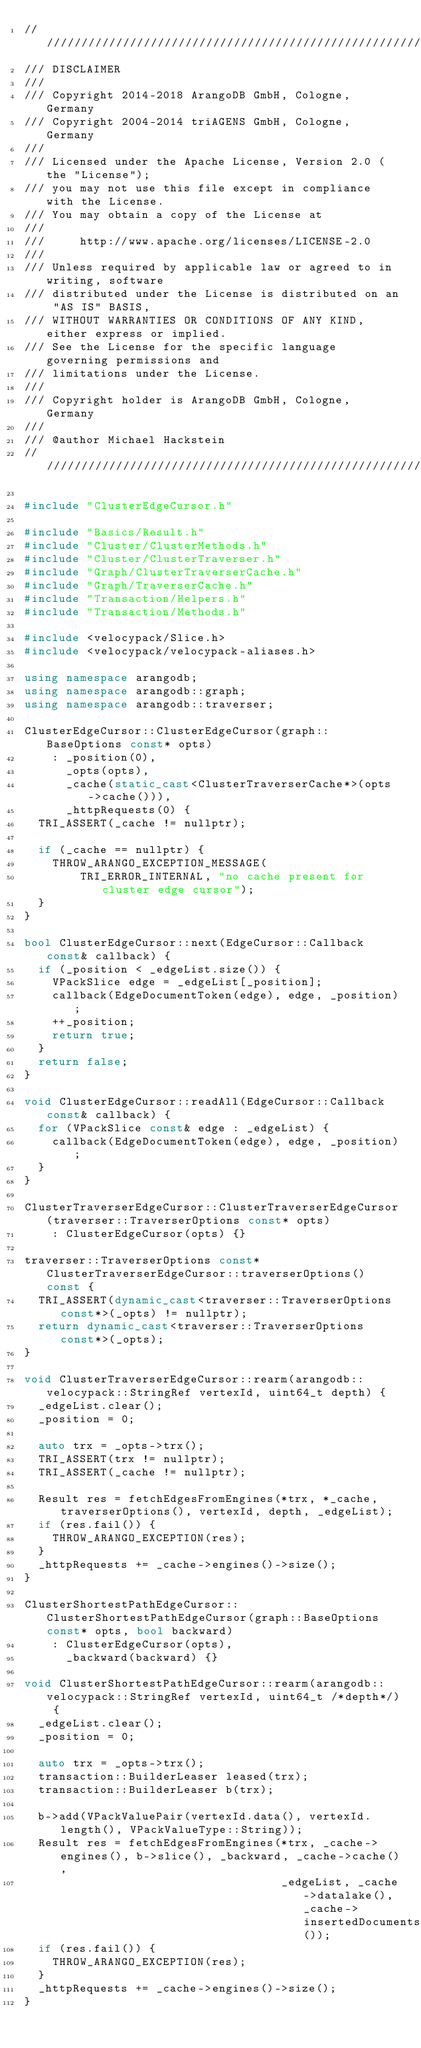<code> <loc_0><loc_0><loc_500><loc_500><_C++_>////////////////////////////////////////////////////////////////////////////////
/// DISCLAIMER
///
/// Copyright 2014-2018 ArangoDB GmbH, Cologne, Germany
/// Copyright 2004-2014 triAGENS GmbH, Cologne, Germany
///
/// Licensed under the Apache License, Version 2.0 (the "License");
/// you may not use this file except in compliance with the License.
/// You may obtain a copy of the License at
///
///     http://www.apache.org/licenses/LICENSE-2.0
///
/// Unless required by applicable law or agreed to in writing, software
/// distributed under the License is distributed on an "AS IS" BASIS,
/// WITHOUT WARRANTIES OR CONDITIONS OF ANY KIND, either express or implied.
/// See the License for the specific language governing permissions and
/// limitations under the License.
///
/// Copyright holder is ArangoDB GmbH, Cologne, Germany
///
/// @author Michael Hackstein
////////////////////////////////////////////////////////////////////////////////

#include "ClusterEdgeCursor.h"

#include "Basics/Result.h"
#include "Cluster/ClusterMethods.h"
#include "Cluster/ClusterTraverser.h"
#include "Graph/ClusterTraverserCache.h"
#include "Graph/TraverserCache.h"
#include "Transaction/Helpers.h"
#include "Transaction/Methods.h"

#include <velocypack/Slice.h>
#include <velocypack/velocypack-aliases.h>

using namespace arangodb;
using namespace arangodb::graph;
using namespace arangodb::traverser;

ClusterEdgeCursor::ClusterEdgeCursor(graph::BaseOptions const* opts) 
    : _position(0),
      _opts(opts),
      _cache(static_cast<ClusterTraverserCache*>(opts->cache())),
      _httpRequests(0) {
  TRI_ASSERT(_cache != nullptr);

  if (_cache == nullptr) {
    THROW_ARANGO_EXCEPTION_MESSAGE(
        TRI_ERROR_INTERNAL, "no cache present for cluster edge cursor");
  }
}

bool ClusterEdgeCursor::next(EdgeCursor::Callback const& callback) {
  if (_position < _edgeList.size()) {
    VPackSlice edge = _edgeList[_position];
    callback(EdgeDocumentToken(edge), edge, _position);
    ++_position;
    return true;
  }
  return false;
}

void ClusterEdgeCursor::readAll(EdgeCursor::Callback const& callback) {
  for (VPackSlice const& edge : _edgeList) {
    callback(EdgeDocumentToken(edge), edge, _position);
  }
}
  
ClusterTraverserEdgeCursor::ClusterTraverserEdgeCursor(traverser::TraverserOptions const* opts)
    : ClusterEdgeCursor(opts) {}

traverser::TraverserOptions const* ClusterTraverserEdgeCursor::traverserOptions() const {
  TRI_ASSERT(dynamic_cast<traverser::TraverserOptions const*>(_opts) != nullptr);
  return dynamic_cast<traverser::TraverserOptions const*>(_opts);
}

void ClusterTraverserEdgeCursor::rearm(arangodb::velocypack::StringRef vertexId, uint64_t depth) {
  _edgeList.clear();
  _position = 0;

  auto trx = _opts->trx();
  TRI_ASSERT(trx != nullptr);
  TRI_ASSERT(_cache != nullptr);

  Result res = fetchEdgesFromEngines(*trx, *_cache, traverserOptions(), vertexId, depth, _edgeList);
  if (res.fail()) {
    THROW_ARANGO_EXCEPTION(res);
  }
  _httpRequests += _cache->engines()->size();
}

ClusterShortestPathEdgeCursor::ClusterShortestPathEdgeCursor(graph::BaseOptions const* opts, bool backward)
    : ClusterEdgeCursor(opts),
      _backward(backward) {}

void ClusterShortestPathEdgeCursor::rearm(arangodb::velocypack::StringRef vertexId, uint64_t /*depth*/) {
  _edgeList.clear();
  _position = 0;

  auto trx = _opts->trx();
  transaction::BuilderLeaser leased(trx);
  transaction::BuilderLeaser b(trx);

  b->add(VPackValuePair(vertexId.data(), vertexId.length(), VPackValueType::String));
  Result res = fetchEdgesFromEngines(*trx, _cache->engines(), b->slice(), _backward, _cache->cache(),
                                     _edgeList, _cache->datalake(), _cache->insertedDocuments());
  if (res.fail()) {
    THROW_ARANGO_EXCEPTION(res);
  }
  _httpRequests += _cache->engines()->size();
}
</code> 